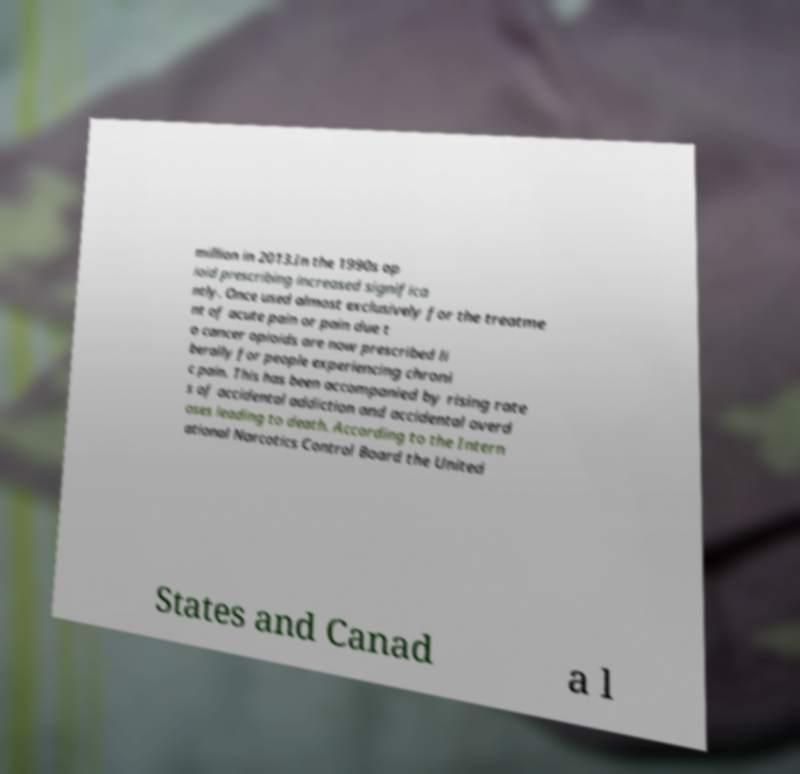I need the written content from this picture converted into text. Can you do that? million in 2013.In the 1990s op ioid prescribing increased significa ntly. Once used almost exclusively for the treatme nt of acute pain or pain due t o cancer opioids are now prescribed li berally for people experiencing chroni c pain. This has been accompanied by rising rate s of accidental addiction and accidental overd oses leading to death. According to the Intern ational Narcotics Control Board the United States and Canad a l 